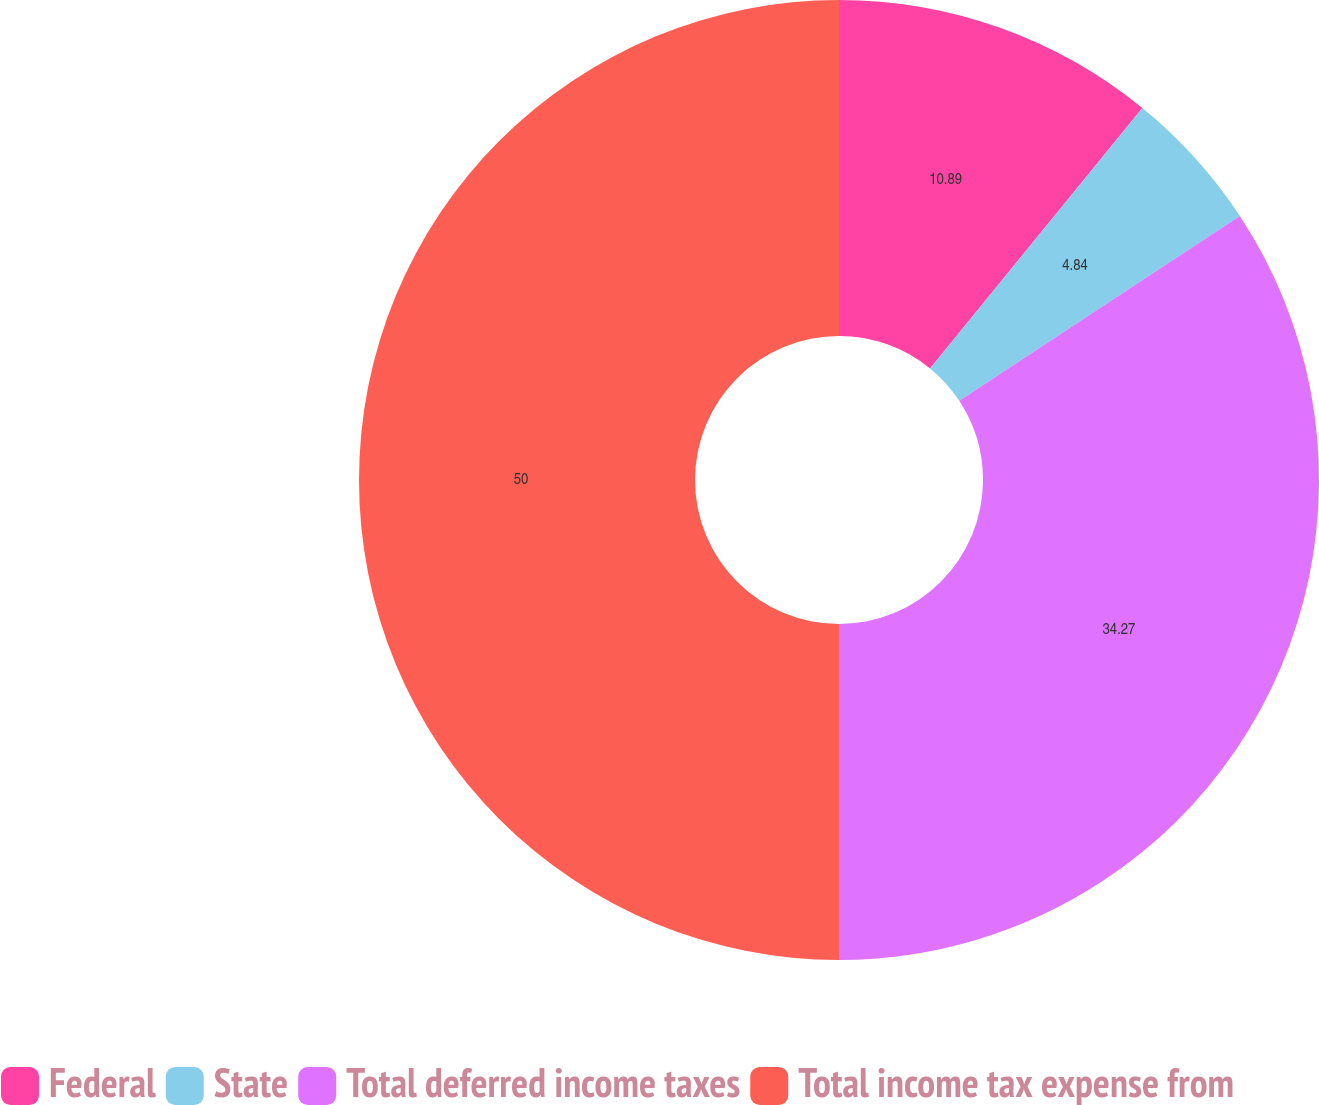Convert chart to OTSL. <chart><loc_0><loc_0><loc_500><loc_500><pie_chart><fcel>Federal<fcel>State<fcel>Total deferred income taxes<fcel>Total income tax expense from<nl><fcel>10.89%<fcel>4.84%<fcel>34.27%<fcel>50.0%<nl></chart> 